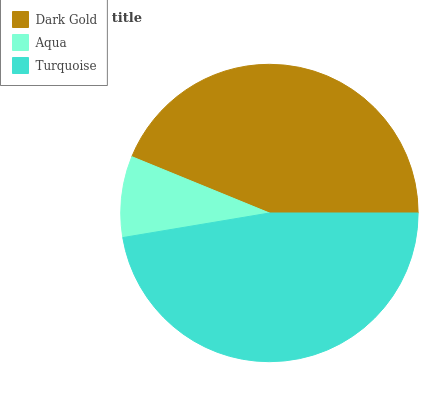Is Aqua the minimum?
Answer yes or no. Yes. Is Turquoise the maximum?
Answer yes or no. Yes. Is Turquoise the minimum?
Answer yes or no. No. Is Aqua the maximum?
Answer yes or no. No. Is Turquoise greater than Aqua?
Answer yes or no. Yes. Is Aqua less than Turquoise?
Answer yes or no. Yes. Is Aqua greater than Turquoise?
Answer yes or no. No. Is Turquoise less than Aqua?
Answer yes or no. No. Is Dark Gold the high median?
Answer yes or no. Yes. Is Dark Gold the low median?
Answer yes or no. Yes. Is Turquoise the high median?
Answer yes or no. No. Is Aqua the low median?
Answer yes or no. No. 